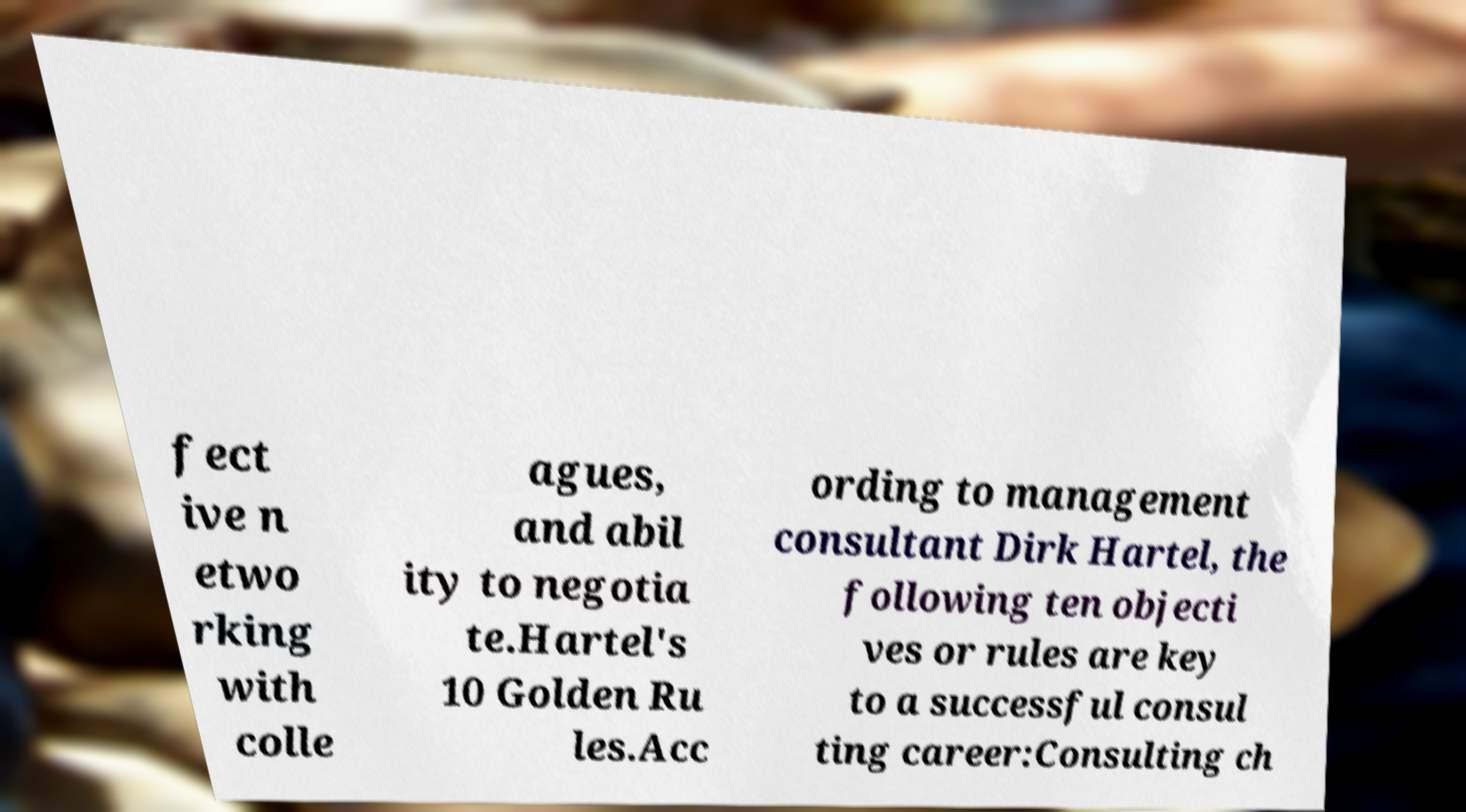Can you accurately transcribe the text from the provided image for me? fect ive n etwo rking with colle agues, and abil ity to negotia te.Hartel's 10 Golden Ru les.Acc ording to management consultant Dirk Hartel, the following ten objecti ves or rules are key to a successful consul ting career:Consulting ch 